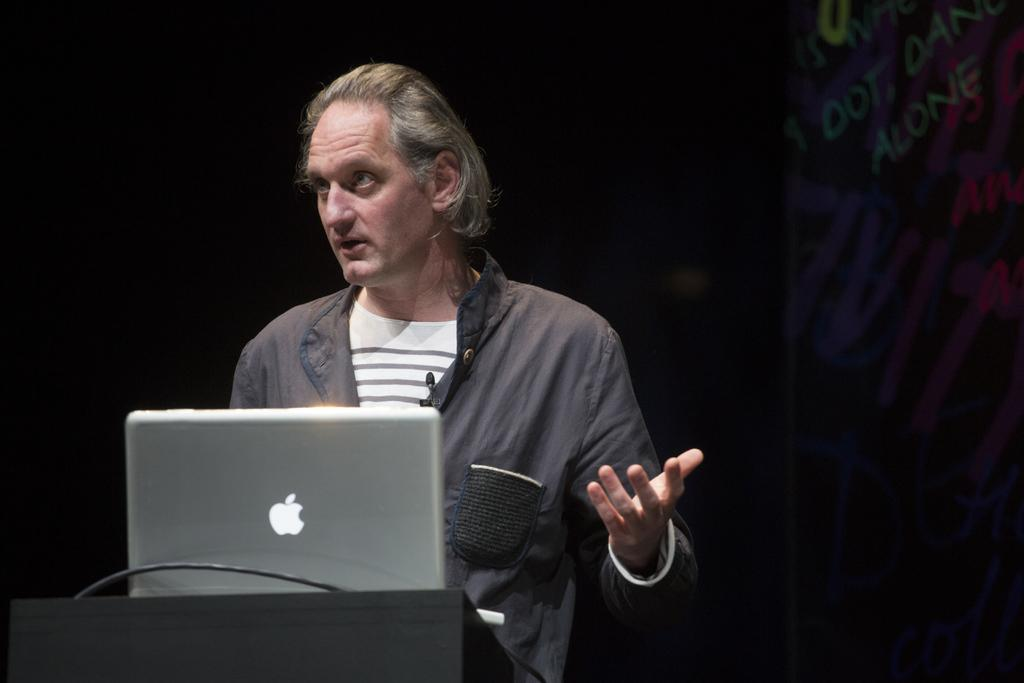Who is present in the image? There is a man in the image. What is the man wearing? The man is wearing a gray jacket. What electronic device can be seen in the image? There is a laptop in the image. How would you describe the lighting in the image? The image is dark. What type of brass instrument is the man playing in the image? There is no brass instrument present in the image; the man is not playing any musical instrument. How does the pollution affect the man in the image? There is no mention of pollution in the image, so we cannot determine its effect on the man. 